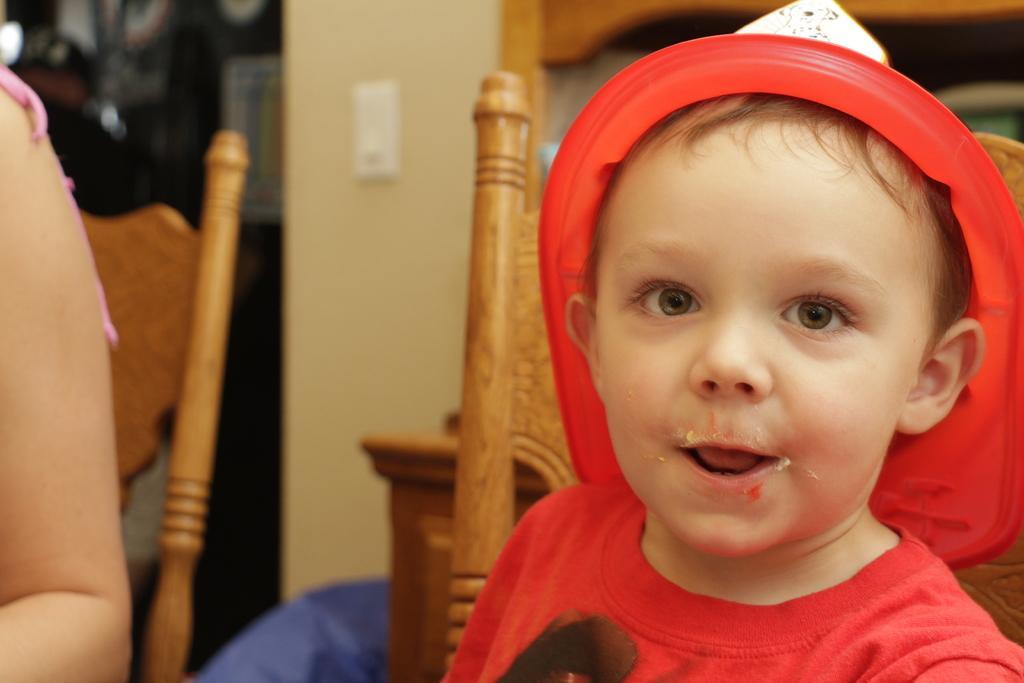How would you summarize this image in a sentence or two? In this picture we can see a child smiling and a person's hand. In the background we can see chairs, wall and some objects. 